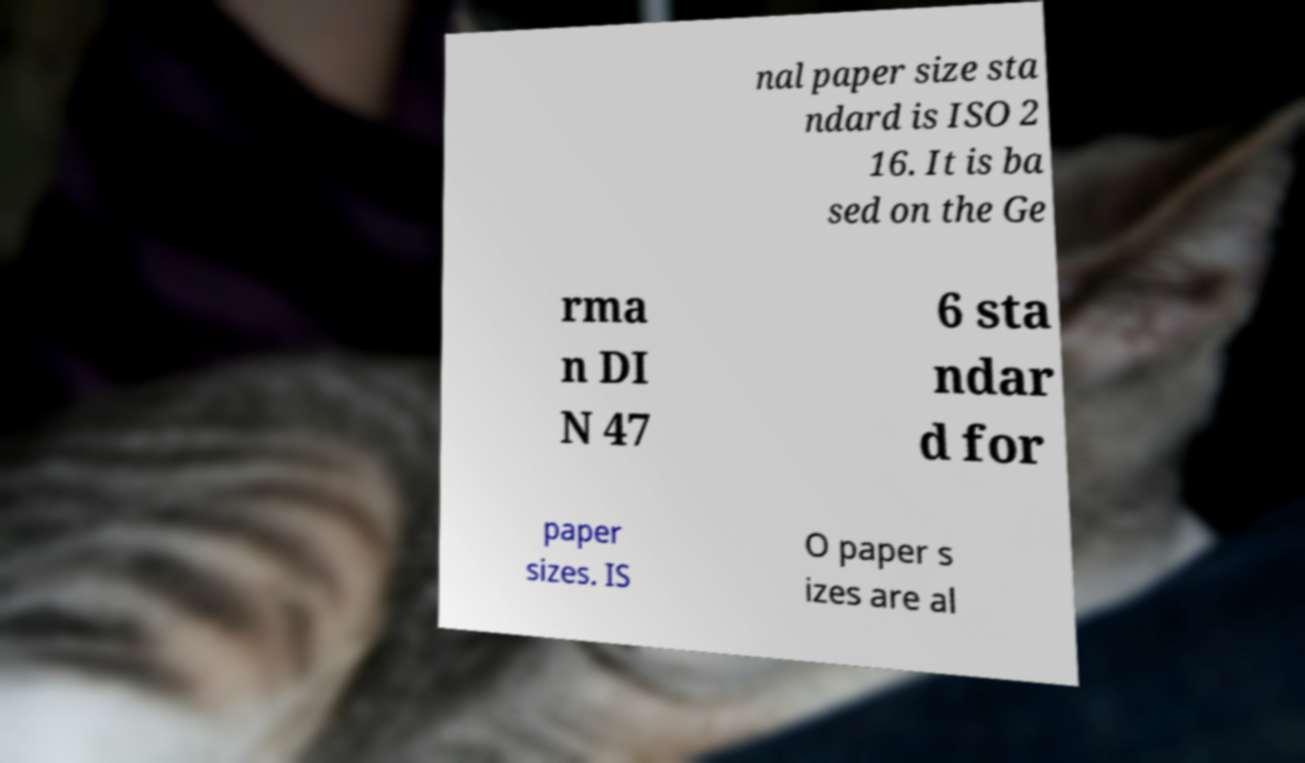Can you accurately transcribe the text from the provided image for me? nal paper size sta ndard is ISO 2 16. It is ba sed on the Ge rma n DI N 47 6 sta ndar d for paper sizes. IS O paper s izes are al 